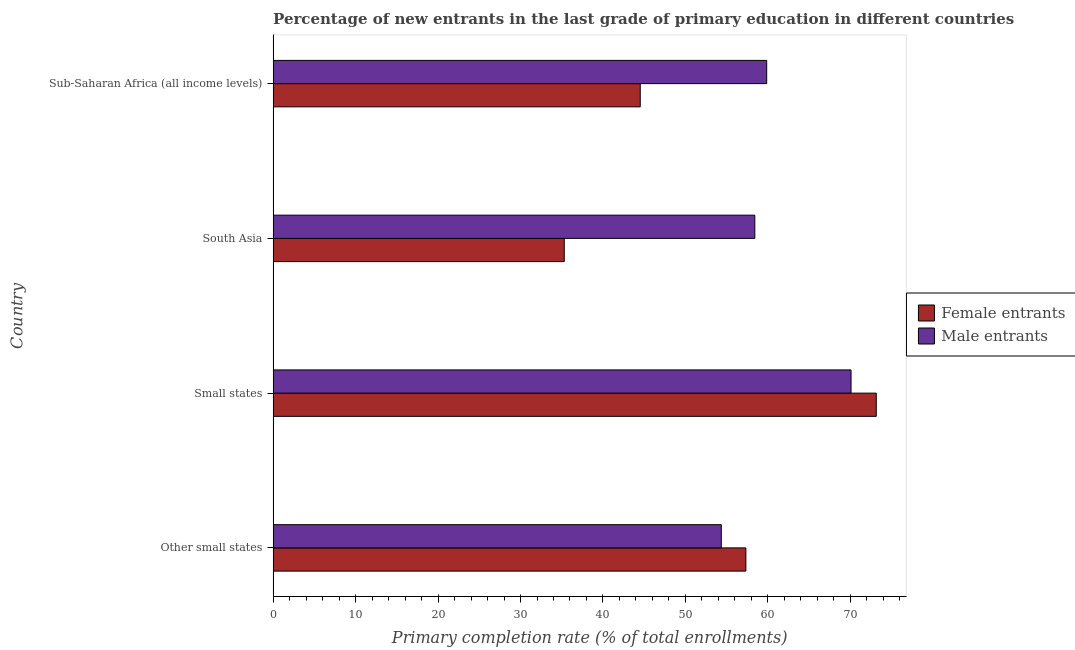How many different coloured bars are there?
Your response must be concise. 2. How many groups of bars are there?
Give a very brief answer. 4. Are the number of bars on each tick of the Y-axis equal?
Your answer should be very brief. Yes. How many bars are there on the 4th tick from the top?
Offer a terse response. 2. What is the label of the 1st group of bars from the top?
Ensure brevity in your answer.  Sub-Saharan Africa (all income levels). What is the primary completion rate of female entrants in South Asia?
Provide a short and direct response. 35.31. Across all countries, what is the maximum primary completion rate of male entrants?
Provide a short and direct response. 70.08. Across all countries, what is the minimum primary completion rate of female entrants?
Your answer should be very brief. 35.31. In which country was the primary completion rate of female entrants maximum?
Your answer should be compact. Small states. In which country was the primary completion rate of female entrants minimum?
Give a very brief answer. South Asia. What is the total primary completion rate of female entrants in the graph?
Provide a succinct answer. 210.3. What is the difference between the primary completion rate of female entrants in Other small states and that in South Asia?
Your response must be concise. 22.02. What is the difference between the primary completion rate of female entrants in Small states and the primary completion rate of male entrants in Sub-Saharan Africa (all income levels)?
Make the answer very short. 13.29. What is the average primary completion rate of male entrants per country?
Provide a succinct answer. 60.67. What is the difference between the primary completion rate of male entrants and primary completion rate of female entrants in Other small states?
Offer a very short reply. -2.98. What is the ratio of the primary completion rate of male entrants in South Asia to that in Sub-Saharan Africa (all income levels)?
Make the answer very short. 0.98. What is the difference between the highest and the second highest primary completion rate of male entrants?
Offer a terse response. 10.23. What is the difference between the highest and the lowest primary completion rate of male entrants?
Your answer should be very brief. 15.74. What does the 2nd bar from the top in Other small states represents?
Make the answer very short. Female entrants. What does the 2nd bar from the bottom in South Asia represents?
Offer a very short reply. Male entrants. How many bars are there?
Make the answer very short. 8. What is the difference between two consecutive major ticks on the X-axis?
Your response must be concise. 10. Are the values on the major ticks of X-axis written in scientific E-notation?
Ensure brevity in your answer.  No. Does the graph contain grids?
Offer a very short reply. No. What is the title of the graph?
Your response must be concise. Percentage of new entrants in the last grade of primary education in different countries. What is the label or title of the X-axis?
Offer a terse response. Primary completion rate (% of total enrollments). What is the label or title of the Y-axis?
Offer a very short reply. Country. What is the Primary completion rate (% of total enrollments) of Female entrants in Other small states?
Your response must be concise. 57.33. What is the Primary completion rate (% of total enrollments) of Male entrants in Other small states?
Your answer should be very brief. 54.35. What is the Primary completion rate (% of total enrollments) of Female entrants in Small states?
Offer a very short reply. 73.14. What is the Primary completion rate (% of total enrollments) of Male entrants in Small states?
Ensure brevity in your answer.  70.08. What is the Primary completion rate (% of total enrollments) of Female entrants in South Asia?
Provide a succinct answer. 35.31. What is the Primary completion rate (% of total enrollments) in Male entrants in South Asia?
Offer a very short reply. 58.41. What is the Primary completion rate (% of total enrollments) in Female entrants in Sub-Saharan Africa (all income levels)?
Provide a short and direct response. 44.52. What is the Primary completion rate (% of total enrollments) in Male entrants in Sub-Saharan Africa (all income levels)?
Provide a short and direct response. 59.85. Across all countries, what is the maximum Primary completion rate (% of total enrollments) in Female entrants?
Offer a terse response. 73.14. Across all countries, what is the maximum Primary completion rate (% of total enrollments) of Male entrants?
Offer a terse response. 70.08. Across all countries, what is the minimum Primary completion rate (% of total enrollments) in Female entrants?
Your answer should be very brief. 35.31. Across all countries, what is the minimum Primary completion rate (% of total enrollments) in Male entrants?
Give a very brief answer. 54.35. What is the total Primary completion rate (% of total enrollments) in Female entrants in the graph?
Provide a succinct answer. 210.3. What is the total Primary completion rate (% of total enrollments) in Male entrants in the graph?
Give a very brief answer. 242.7. What is the difference between the Primary completion rate (% of total enrollments) in Female entrants in Other small states and that in Small states?
Offer a very short reply. -15.81. What is the difference between the Primary completion rate (% of total enrollments) in Male entrants in Other small states and that in Small states?
Make the answer very short. -15.74. What is the difference between the Primary completion rate (% of total enrollments) in Female entrants in Other small states and that in South Asia?
Offer a terse response. 22.02. What is the difference between the Primary completion rate (% of total enrollments) in Male entrants in Other small states and that in South Asia?
Your answer should be compact. -4.06. What is the difference between the Primary completion rate (% of total enrollments) in Female entrants in Other small states and that in Sub-Saharan Africa (all income levels)?
Offer a very short reply. 12.81. What is the difference between the Primary completion rate (% of total enrollments) in Male entrants in Other small states and that in Sub-Saharan Africa (all income levels)?
Keep it short and to the point. -5.51. What is the difference between the Primary completion rate (% of total enrollments) of Female entrants in Small states and that in South Asia?
Offer a very short reply. 37.84. What is the difference between the Primary completion rate (% of total enrollments) of Male entrants in Small states and that in South Asia?
Provide a short and direct response. 11.67. What is the difference between the Primary completion rate (% of total enrollments) in Female entrants in Small states and that in Sub-Saharan Africa (all income levels)?
Ensure brevity in your answer.  28.62. What is the difference between the Primary completion rate (% of total enrollments) in Male entrants in Small states and that in Sub-Saharan Africa (all income levels)?
Provide a succinct answer. 10.23. What is the difference between the Primary completion rate (% of total enrollments) in Female entrants in South Asia and that in Sub-Saharan Africa (all income levels)?
Your answer should be compact. -9.22. What is the difference between the Primary completion rate (% of total enrollments) of Male entrants in South Asia and that in Sub-Saharan Africa (all income levels)?
Provide a short and direct response. -1.44. What is the difference between the Primary completion rate (% of total enrollments) in Female entrants in Other small states and the Primary completion rate (% of total enrollments) in Male entrants in Small states?
Your answer should be very brief. -12.75. What is the difference between the Primary completion rate (% of total enrollments) in Female entrants in Other small states and the Primary completion rate (% of total enrollments) in Male entrants in South Asia?
Your response must be concise. -1.08. What is the difference between the Primary completion rate (% of total enrollments) in Female entrants in Other small states and the Primary completion rate (% of total enrollments) in Male entrants in Sub-Saharan Africa (all income levels)?
Make the answer very short. -2.52. What is the difference between the Primary completion rate (% of total enrollments) in Female entrants in Small states and the Primary completion rate (% of total enrollments) in Male entrants in South Asia?
Keep it short and to the point. 14.73. What is the difference between the Primary completion rate (% of total enrollments) of Female entrants in Small states and the Primary completion rate (% of total enrollments) of Male entrants in Sub-Saharan Africa (all income levels)?
Provide a short and direct response. 13.29. What is the difference between the Primary completion rate (% of total enrollments) in Female entrants in South Asia and the Primary completion rate (% of total enrollments) in Male entrants in Sub-Saharan Africa (all income levels)?
Provide a succinct answer. -24.55. What is the average Primary completion rate (% of total enrollments) in Female entrants per country?
Offer a very short reply. 52.57. What is the average Primary completion rate (% of total enrollments) of Male entrants per country?
Your answer should be very brief. 60.68. What is the difference between the Primary completion rate (% of total enrollments) in Female entrants and Primary completion rate (% of total enrollments) in Male entrants in Other small states?
Your answer should be very brief. 2.98. What is the difference between the Primary completion rate (% of total enrollments) of Female entrants and Primary completion rate (% of total enrollments) of Male entrants in Small states?
Give a very brief answer. 3.06. What is the difference between the Primary completion rate (% of total enrollments) in Female entrants and Primary completion rate (% of total enrollments) in Male entrants in South Asia?
Provide a short and direct response. -23.11. What is the difference between the Primary completion rate (% of total enrollments) in Female entrants and Primary completion rate (% of total enrollments) in Male entrants in Sub-Saharan Africa (all income levels)?
Provide a short and direct response. -15.33. What is the ratio of the Primary completion rate (% of total enrollments) in Female entrants in Other small states to that in Small states?
Make the answer very short. 0.78. What is the ratio of the Primary completion rate (% of total enrollments) in Male entrants in Other small states to that in Small states?
Ensure brevity in your answer.  0.78. What is the ratio of the Primary completion rate (% of total enrollments) of Female entrants in Other small states to that in South Asia?
Offer a terse response. 1.62. What is the ratio of the Primary completion rate (% of total enrollments) in Male entrants in Other small states to that in South Asia?
Offer a terse response. 0.93. What is the ratio of the Primary completion rate (% of total enrollments) of Female entrants in Other small states to that in Sub-Saharan Africa (all income levels)?
Provide a short and direct response. 1.29. What is the ratio of the Primary completion rate (% of total enrollments) of Male entrants in Other small states to that in Sub-Saharan Africa (all income levels)?
Offer a terse response. 0.91. What is the ratio of the Primary completion rate (% of total enrollments) of Female entrants in Small states to that in South Asia?
Your answer should be compact. 2.07. What is the ratio of the Primary completion rate (% of total enrollments) in Male entrants in Small states to that in South Asia?
Provide a succinct answer. 1.2. What is the ratio of the Primary completion rate (% of total enrollments) in Female entrants in Small states to that in Sub-Saharan Africa (all income levels)?
Ensure brevity in your answer.  1.64. What is the ratio of the Primary completion rate (% of total enrollments) of Male entrants in Small states to that in Sub-Saharan Africa (all income levels)?
Provide a short and direct response. 1.17. What is the ratio of the Primary completion rate (% of total enrollments) of Female entrants in South Asia to that in Sub-Saharan Africa (all income levels)?
Offer a terse response. 0.79. What is the ratio of the Primary completion rate (% of total enrollments) of Male entrants in South Asia to that in Sub-Saharan Africa (all income levels)?
Make the answer very short. 0.98. What is the difference between the highest and the second highest Primary completion rate (% of total enrollments) in Female entrants?
Offer a very short reply. 15.81. What is the difference between the highest and the second highest Primary completion rate (% of total enrollments) in Male entrants?
Your response must be concise. 10.23. What is the difference between the highest and the lowest Primary completion rate (% of total enrollments) in Female entrants?
Your answer should be very brief. 37.84. What is the difference between the highest and the lowest Primary completion rate (% of total enrollments) of Male entrants?
Your answer should be compact. 15.74. 